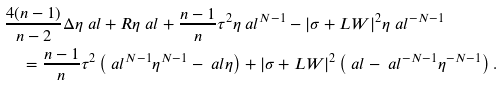Convert formula to latex. <formula><loc_0><loc_0><loc_500><loc_500>& \frac { 4 ( n - 1 ) } { n - 2 } \Delta \eta _ { \ } a l + R \eta _ { \ } a l + \frac { n - 1 } { n } \tau ^ { 2 } \eta _ { \ } a l ^ { N - 1 } - | \sigma + L W | ^ { 2 } \eta _ { \ } a l ^ { - N - 1 } \\ & \quad = \frac { n - 1 } { n } \tau ^ { 2 } \left ( \ a l ^ { N - 1 } \eta ^ { N - 1 } - \ a l \eta \right ) + | \sigma + L W | ^ { 2 } \left ( \ a l - \ a l ^ { - N - 1 } \eta ^ { - N - 1 } \right ) .</formula> 